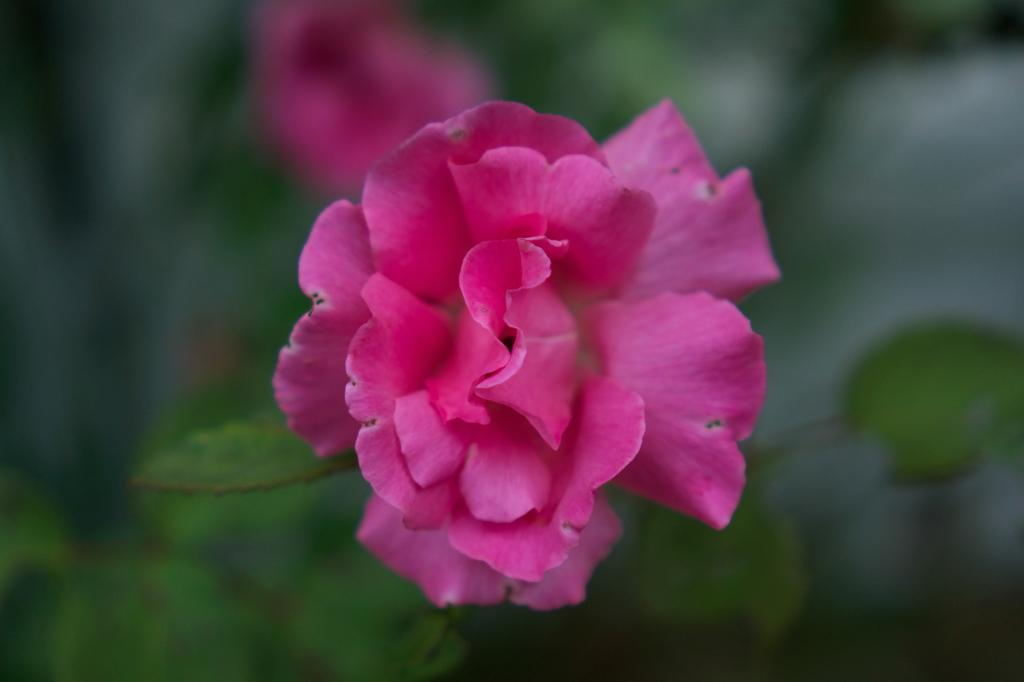What type of flower is in the image? There is a rose flower in the image. Can you describe the background of the image? The background of the image is blurred. What is the taste of the calendar in the image? There is no calendar present in the image, and therefore no taste can be attributed to it. 